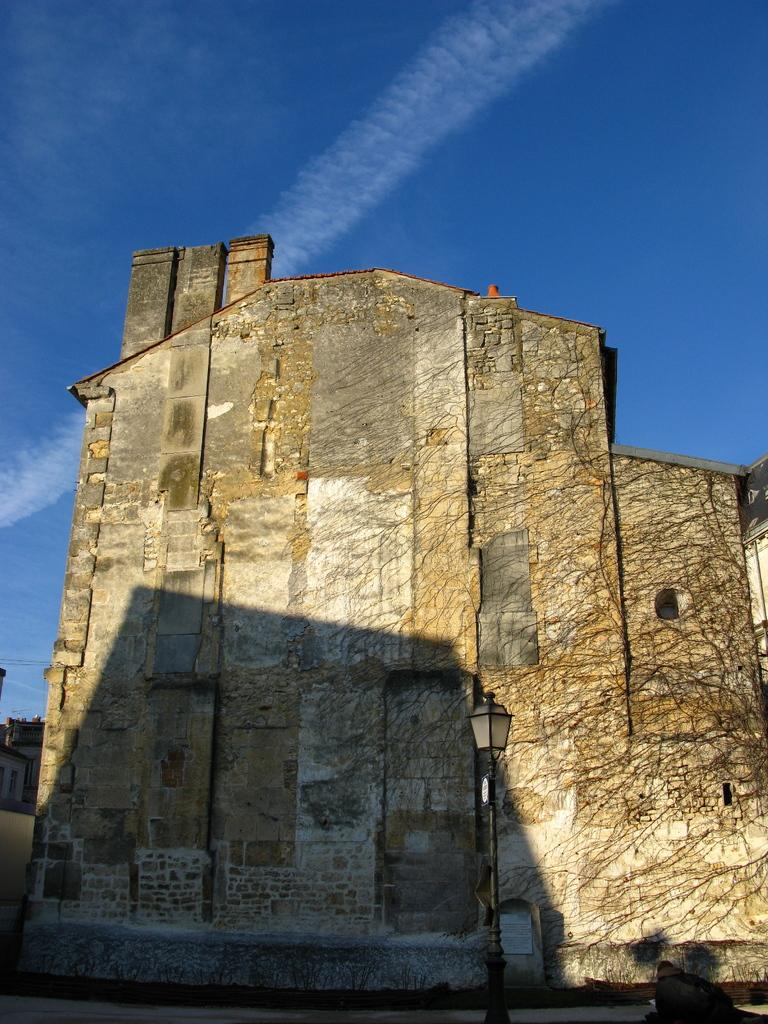What is the main structure in the image? There is a monument in the image. What else can be seen in the image besides the monument? There is a pole, buildings, cables, and the sky visible in the image. Can you describe the sky in the image? The sky is visible in the image, and there are clouds present. Reasoning: Let' Let's think step by step in order to produce the conversation. We start by identifying the main subject in the image, which is the monument. Then, we expand the conversation to include other elements that are also visible, such as the pole, buildings, cables, and the sky. Each question is designed to elicit a specific detail about the image that is known from the provided facts. Absurd Question/Answer: How does the monument say good-bye to the people in the image? The monument does not say good-bye to people in the image, as it is an inanimate object. What type of change can be seen in the image? There is no specific change mentioned in the image; it simply depicts a monument, pole, buildings, cables, and the sky. Is there an umbrella visible in the image? No, there is no umbrella present in the image. 